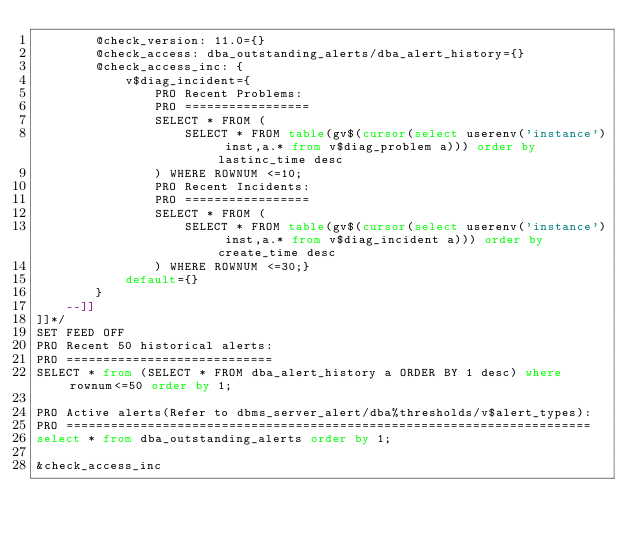Convert code to text. <code><loc_0><loc_0><loc_500><loc_500><_SQL_>        @check_version: 11.0={}
        @check_access: dba_outstanding_alerts/dba_alert_history={}
        @check_access_inc: {
            v$diag_incident={
                PRO Recent Problems:
                PRO =================
                SELECT * FROM (
                    SELECT * FROM table(gv$(cursor(select userenv('instance') inst,a.* from v$diag_problem a))) order by lastinc_time desc
                ) WHERE ROWNUM <=10;
                PRO Recent Incidents:
                PRO =================
                SELECT * FROM (
                    SELECT * FROM table(gv$(cursor(select userenv('instance') inst,a.* from v$diag_incident a))) order by create_time desc
                ) WHERE ROWNUM <=30;}
            default={}
        }
    --]]
]]*/
SET FEED OFF
PRO Recent 50 historical alerts:
PRO ============================
SELECT * from (SELECT * FROM dba_alert_history a ORDER BY 1 desc) where rownum<=50 order by 1;

PRO Active alerts(Refer to dbms_server_alert/dba%thresholds/v$alert_types):
PRO =======================================================================
select * from dba_outstanding_alerts order by 1;

&check_access_inc</code> 